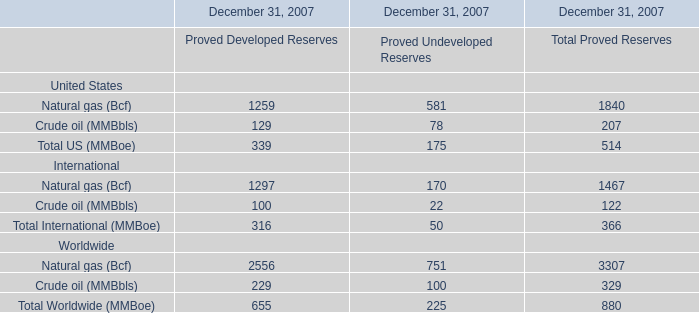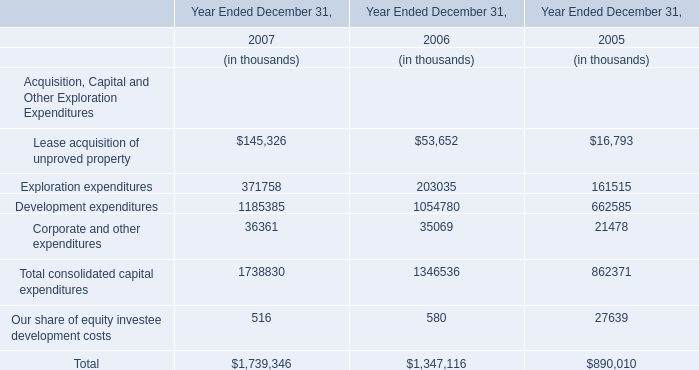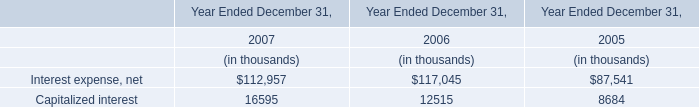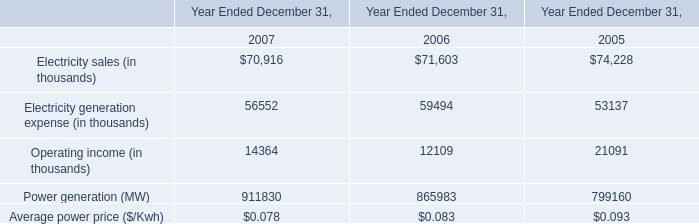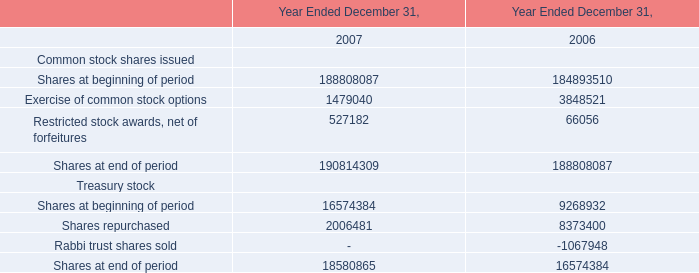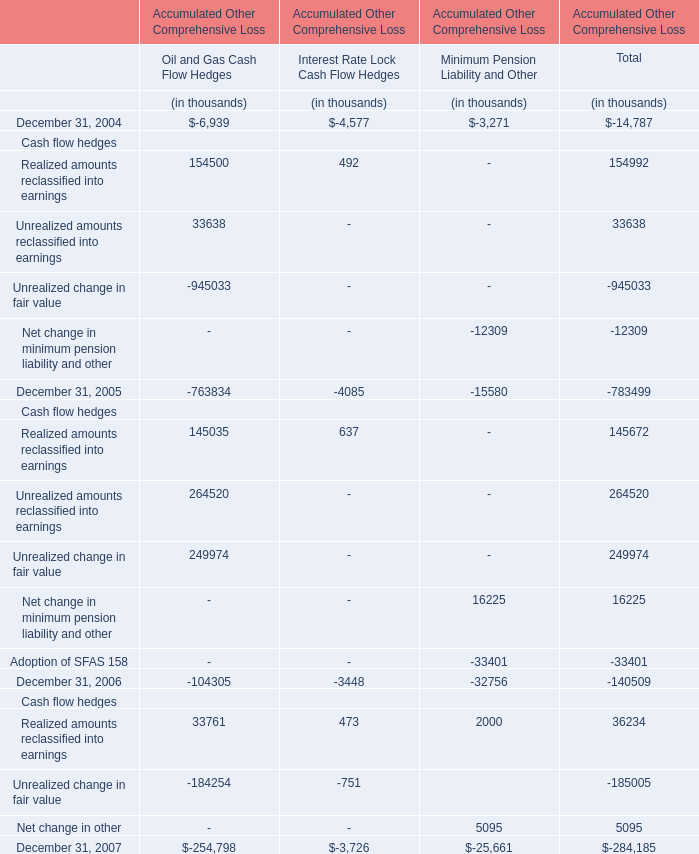In the year with largest amount of Shares at beginning of period, what's the increasing rate of Exercise of common stock options? 
Computations: ((1479040 - 3848521) / 1479040)
Answer: -1.60204. 